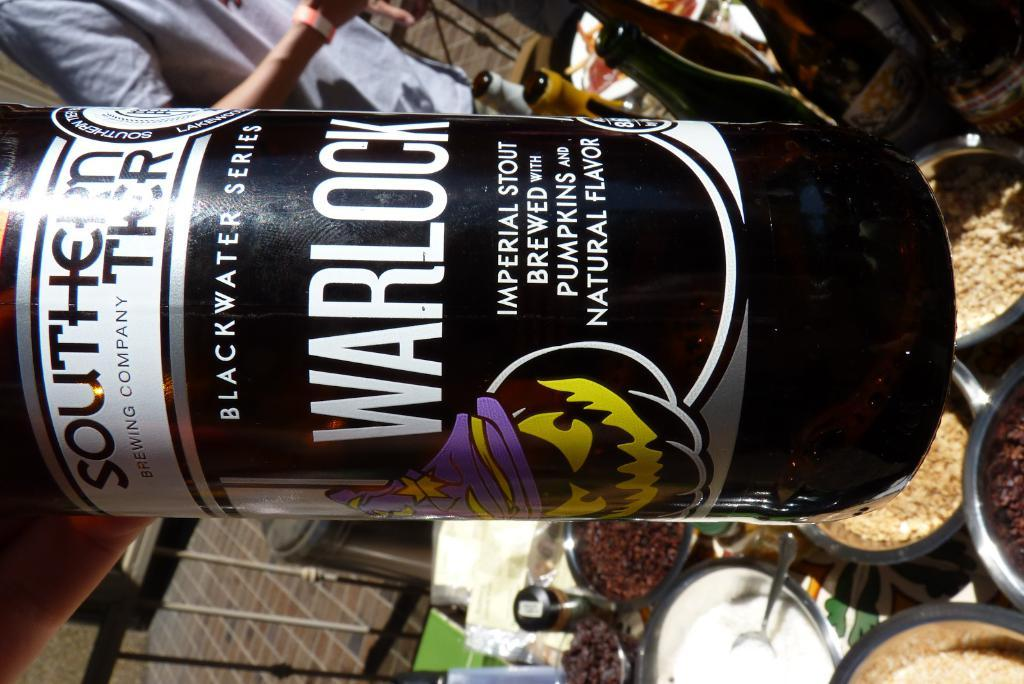What is the main object with text in the image? There is a bottle with text in the image. What else can be seen in the image besides the bottle with text? There are food items, other bottles, and other objects on the table in the image. Can you describe the person in the image? Unfortunately, the facts provided do not mention any details about the person in the image. What type of food items are visible in the image? The facts provided do not specify the type of food items in the image. How does the patch of waves on the table contribute to the image? There are no waves or patches present in the image; it only contains a bottle with text, food items, other bottles, and other objects on the table. 